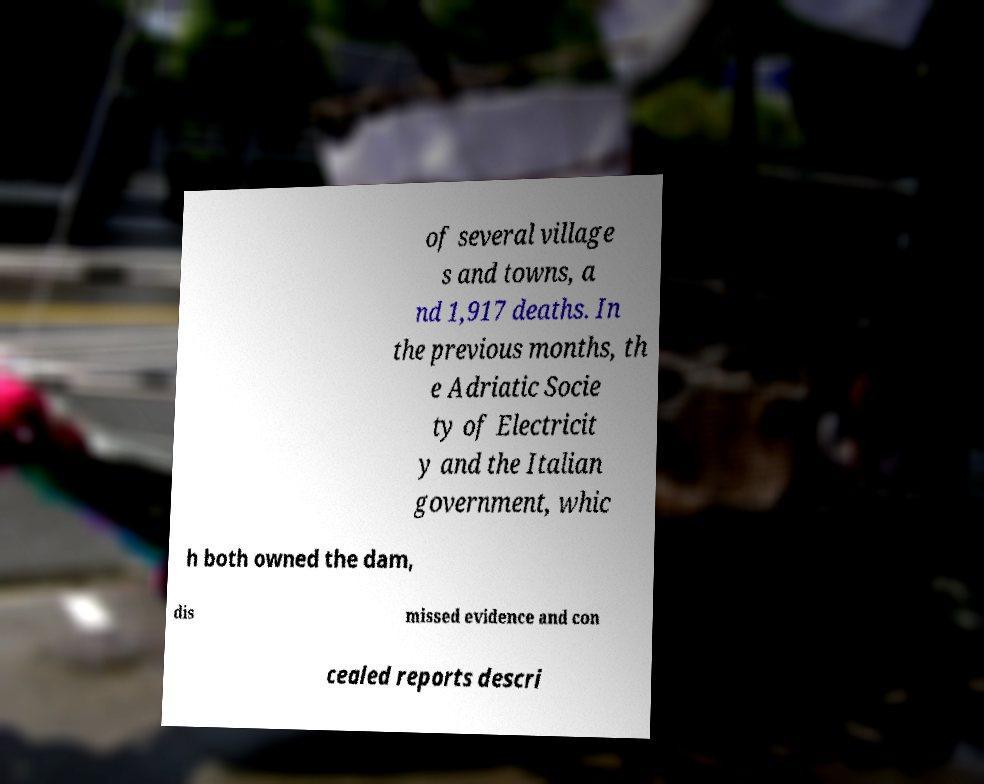Can you read and provide the text displayed in the image?This photo seems to have some interesting text. Can you extract and type it out for me? of several village s and towns, a nd 1,917 deaths. In the previous months, th e Adriatic Socie ty of Electricit y and the Italian government, whic h both owned the dam, dis missed evidence and con cealed reports descri 